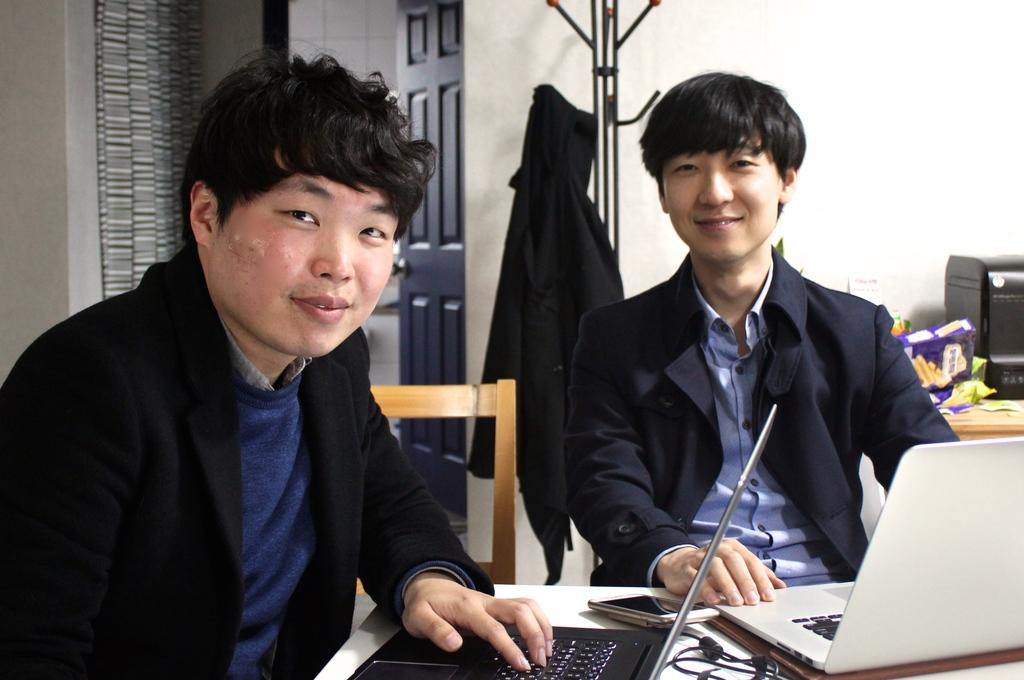What is the color of the wall in the image? The wall in the image is white. What can be found on the wall? There is a door in the image. What appliance is present in the image? There is an oven in the image. How many tables are in the image? There are tables in the image. What are the two people wearing in the image? The two people are wearing black color jackets in the image. What are the two people doing in the image? The two people are sitting on chairs in the image. What electronic devices are on the table? There are laptops on the table in the image. Can you tell me how many sofas are in the image? There are no sofas present in the image. What observation can be made about the people's throats in the image? There is no information about the people's throats in the image. 